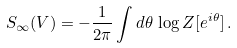Convert formula to latex. <formula><loc_0><loc_0><loc_500><loc_500>S _ { \infty } ( V ) = - \frac { 1 } { 2 \pi } \int d \theta \, \log Z [ e ^ { i \theta } ] \, .</formula> 